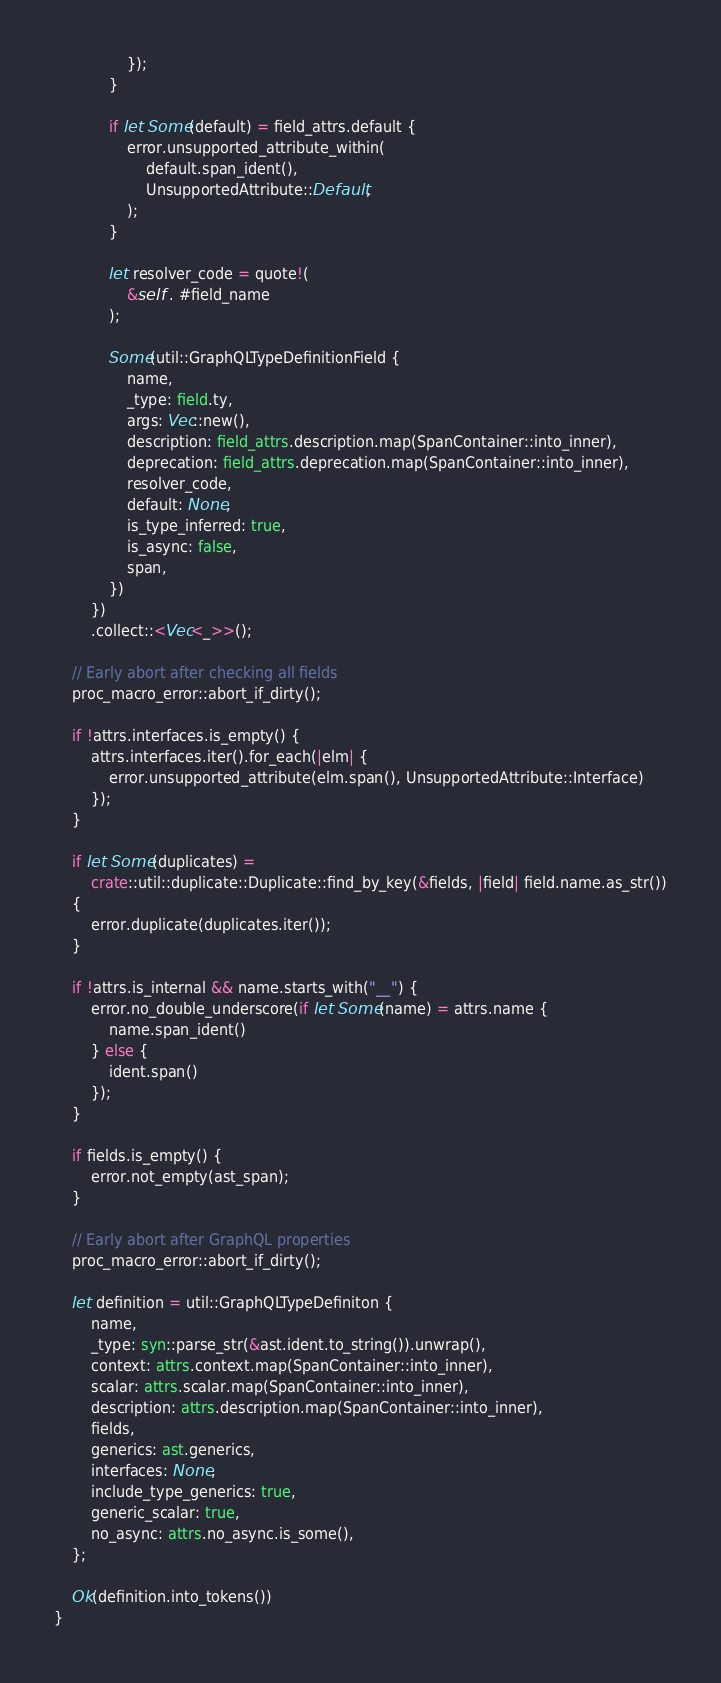Convert code to text. <code><loc_0><loc_0><loc_500><loc_500><_Rust_>                });
            }

            if let Some(default) = field_attrs.default {
                error.unsupported_attribute_within(
                    default.span_ident(),
                    UnsupportedAttribute::Default,
                );
            }

            let resolver_code = quote!(
                &self . #field_name
            );

            Some(util::GraphQLTypeDefinitionField {
                name,
                _type: field.ty,
                args: Vec::new(),
                description: field_attrs.description.map(SpanContainer::into_inner),
                deprecation: field_attrs.deprecation.map(SpanContainer::into_inner),
                resolver_code,
                default: None,
                is_type_inferred: true,
                is_async: false,
                span,
            })
        })
        .collect::<Vec<_>>();

    // Early abort after checking all fields
    proc_macro_error::abort_if_dirty();

    if !attrs.interfaces.is_empty() {
        attrs.interfaces.iter().for_each(|elm| {
            error.unsupported_attribute(elm.span(), UnsupportedAttribute::Interface)
        });
    }

    if let Some(duplicates) =
        crate::util::duplicate::Duplicate::find_by_key(&fields, |field| field.name.as_str())
    {
        error.duplicate(duplicates.iter());
    }

    if !attrs.is_internal && name.starts_with("__") {
        error.no_double_underscore(if let Some(name) = attrs.name {
            name.span_ident()
        } else {
            ident.span()
        });
    }

    if fields.is_empty() {
        error.not_empty(ast_span);
    }

    // Early abort after GraphQL properties
    proc_macro_error::abort_if_dirty();

    let definition = util::GraphQLTypeDefiniton {
        name,
        _type: syn::parse_str(&ast.ident.to_string()).unwrap(),
        context: attrs.context.map(SpanContainer::into_inner),
        scalar: attrs.scalar.map(SpanContainer::into_inner),
        description: attrs.description.map(SpanContainer::into_inner),
        fields,
        generics: ast.generics,
        interfaces: None,
        include_type_generics: true,
        generic_scalar: true,
        no_async: attrs.no_async.is_some(),
    };

    Ok(definition.into_tokens())
}
</code> 